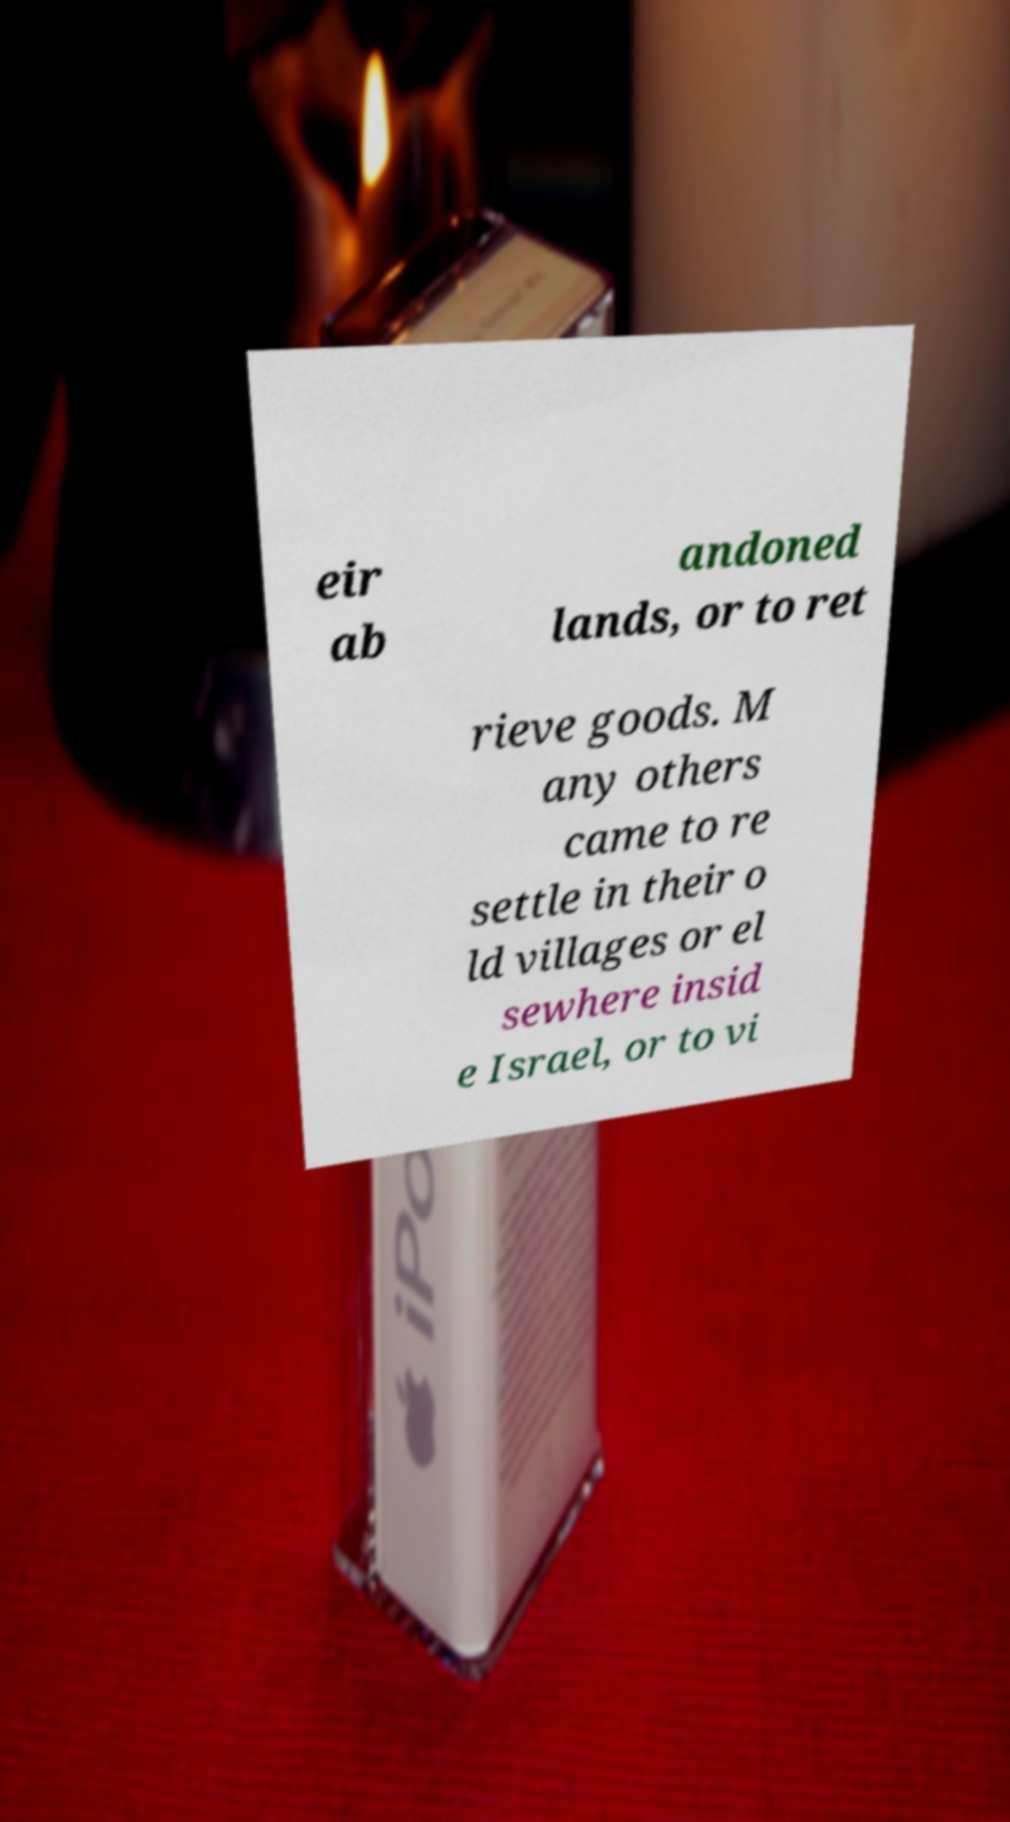There's text embedded in this image that I need extracted. Can you transcribe it verbatim? eir ab andoned lands, or to ret rieve goods. M any others came to re settle in their o ld villages or el sewhere insid e Israel, or to vi 